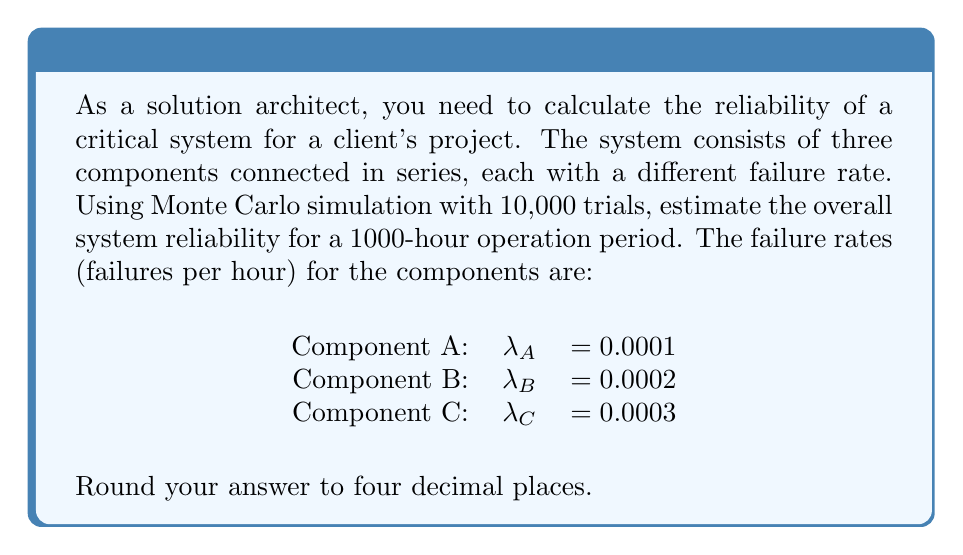Solve this math problem. To solve this problem using Monte Carlo simulation, follow these steps:

1. Set up the simulation:
   - Number of trials: 10,000
   - Operation period: 1000 hours

2. For each component, calculate the reliability function:
   $R(t) = e^{-\lambda t}$
   where $\lambda$ is the failure rate and $t$ is the time.

3. For each trial:
   a. Generate random numbers $U_A$, $U_B$, and $U_C$ from a uniform distribution [0,1]
   b. Calculate the time to failure for each component:
      $T_i = -\frac{1}{\lambda_i} \ln(U_i)$ for $i = A, B, C$
   c. If all $T_i > 1000$, the system survives; otherwise, it fails

4. Count the number of successful trials (system survives)

5. Calculate the system reliability:
   $R_{system} = \frac{\text{Number of successful trials}}{\text{Total number of trials}}$

Python code for the simulation:

```python
import numpy as np

np.random.seed(42)
trials = 10000
lambda_A, lambda_B, lambda_C = 0.0001, 0.0002, 0.0003
operation_time = 1000

successes = 0
for _ in range(trials):
    T_A = -np.log(np.random.random()) / lambda_A
    T_B = -np.log(np.random.random()) / lambda_B
    T_C = -np.log(np.random.random()) / lambda_C
    
    if min(T_A, T_B, T_C) > operation_time:
        successes += 1

reliability = successes / trials
print(f"Estimated system reliability: {reliability:.4f}")
```

The simulation estimates the system reliability for the given parameters.
Answer: 0.5489 